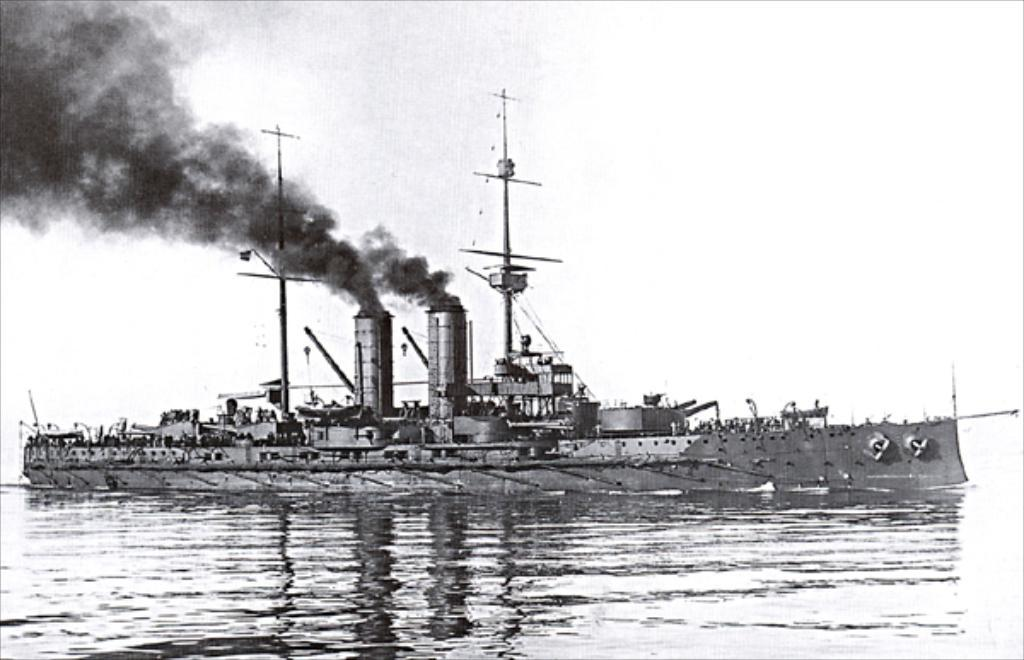What is the main subject of the black and white picture in the image? There is a black and white picture of a ship in the image. Where is the ship located in the image? The ship is on the surface of the water. What can be seen coming from the ship? Black smoke is coming from the ship. What is visible in the background of the image? The sky is visible in the background of the image. Can you see the friend of the ship in the image? There is no friend of the ship present in the image; it only features the ship and the smoke coming from it. Is there any blood visible in the image? There is no blood present in the image. 